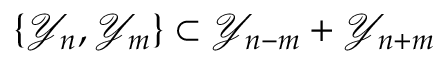Convert formula to latex. <formula><loc_0><loc_0><loc_500><loc_500>\{ \mathcal { Y } _ { n } , \mathcal { Y } _ { m } \} \subset \mathcal { Y } _ { n - m } + \mathcal { Y } _ { n + m }</formula> 